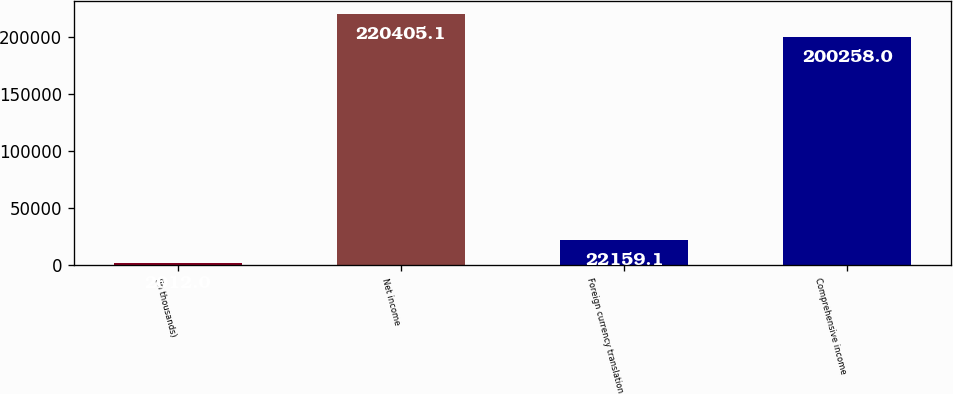Convert chart. <chart><loc_0><loc_0><loc_500><loc_500><bar_chart><fcel>(in thousands)<fcel>Net income<fcel>Foreign currency translation<fcel>Comprehensive income<nl><fcel>2012<fcel>220405<fcel>22159.1<fcel>200258<nl></chart> 